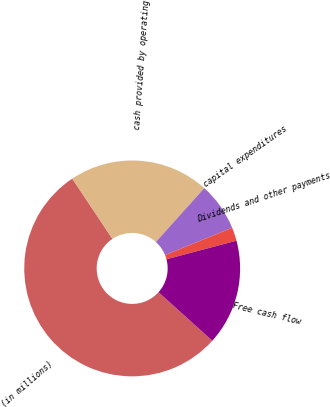<chart> <loc_0><loc_0><loc_500><loc_500><pie_chart><fcel>(in millions)<fcel>cash provided by operating<fcel>capital expenditures<fcel>Dividends and other payments<fcel>Free cash flow<nl><fcel>53.96%<fcel>21.01%<fcel>7.21%<fcel>2.01%<fcel>15.82%<nl></chart> 